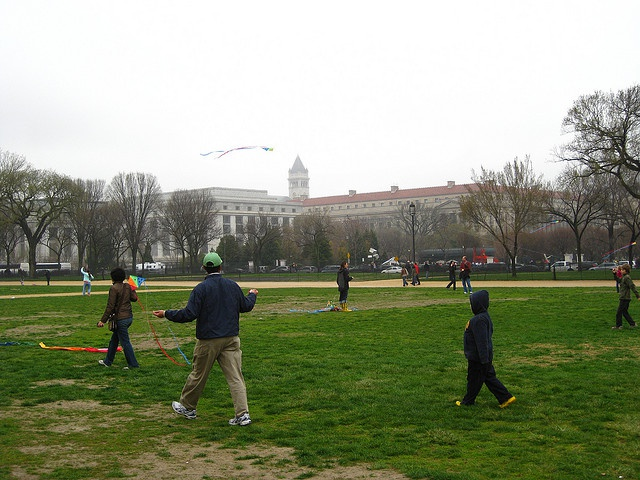Describe the objects in this image and their specific colors. I can see people in white, black, darkgreen, and gray tones, people in white, black, and darkgreen tones, people in white, black, and darkgreen tones, people in white, black, darkgreen, and maroon tones, and people in white, black, olive, gray, and maroon tones in this image. 